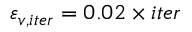Convert formula to latex. <formula><loc_0><loc_0><loc_500><loc_500>\varepsilon _ { v , i t e r } = 0 . 0 2 \times i t e r</formula> 